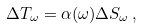Convert formula to latex. <formula><loc_0><loc_0><loc_500><loc_500>\Delta T _ { \omega } = \alpha ( \omega ) \Delta S _ { \omega } \, ,</formula> 